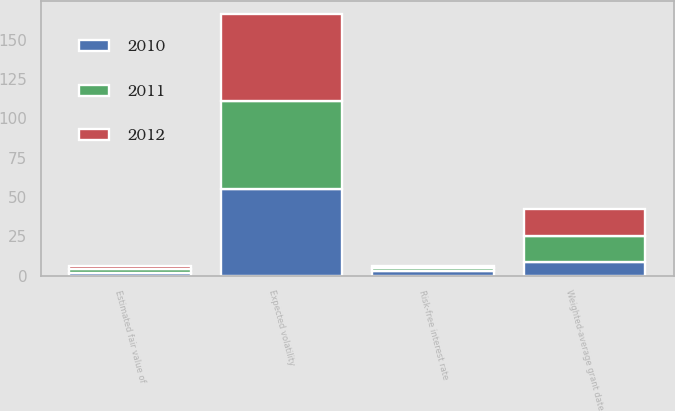Convert chart. <chart><loc_0><loc_0><loc_500><loc_500><stacked_bar_chart><ecel><fcel>Expected volatility<fcel>Risk-free interest rate<fcel>Weighted-average grant date<fcel>Estimated fair value of<nl><fcel>2012<fcel>55<fcel>1.08<fcel>17.23<fcel>2<nl><fcel>2011<fcel>56<fcel>2.26<fcel>16.4<fcel>2<nl><fcel>2010<fcel>55<fcel>2.78<fcel>9.03<fcel>2<nl></chart> 